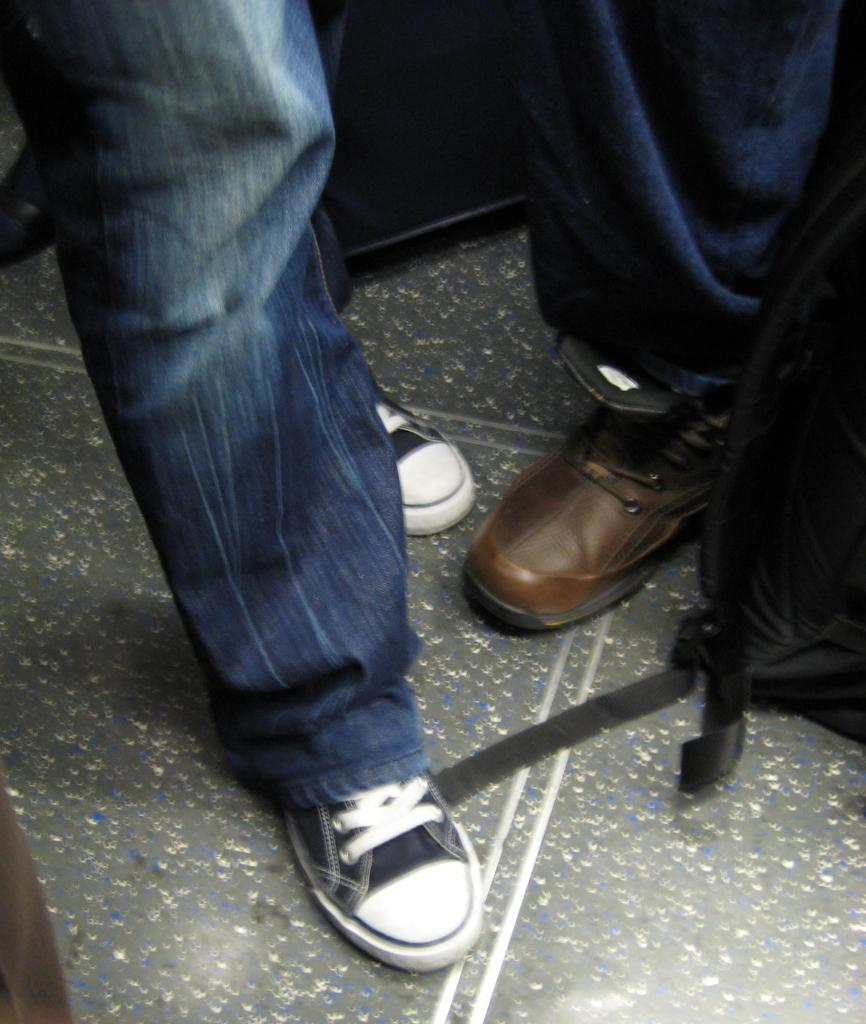What can be seen in the image that belongs to people? There are legs of some persons visible in the image. What object is placed on the ground in the right side of the image? There is a bag placed on the ground in the right side of the image. How many eggs can be seen in the image? There are no eggs visible in the image. What type of hen is present in the image? There is no hen present in the image. 